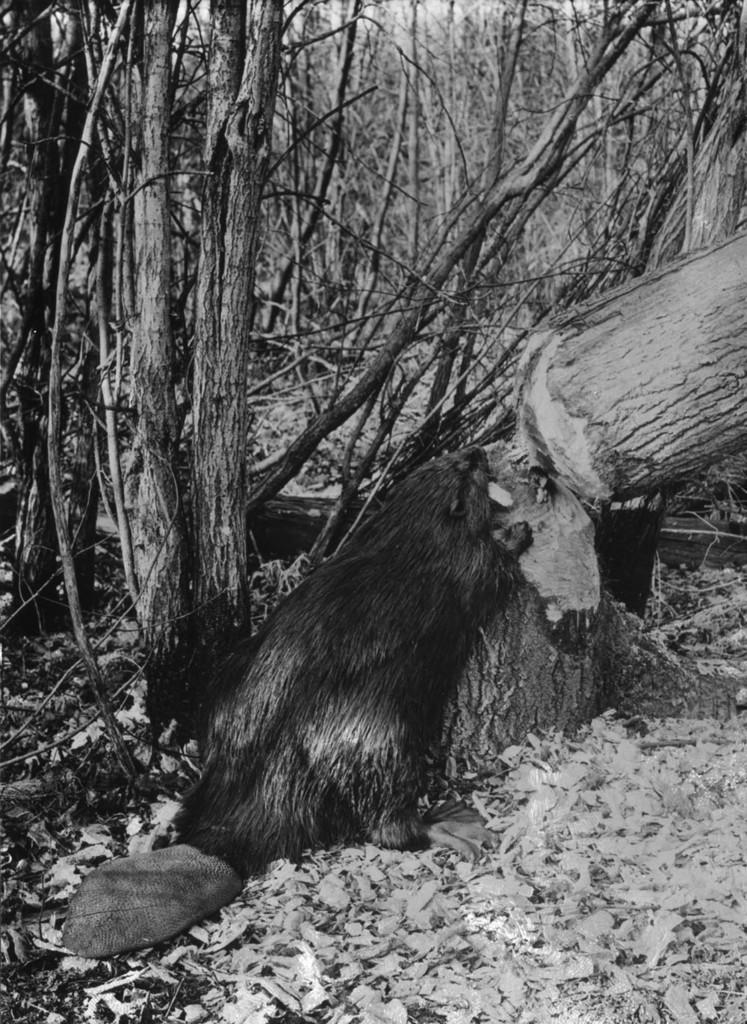How would you summarize this image in a sentence or two? In this image I can see many trees and the image is in black and white. 